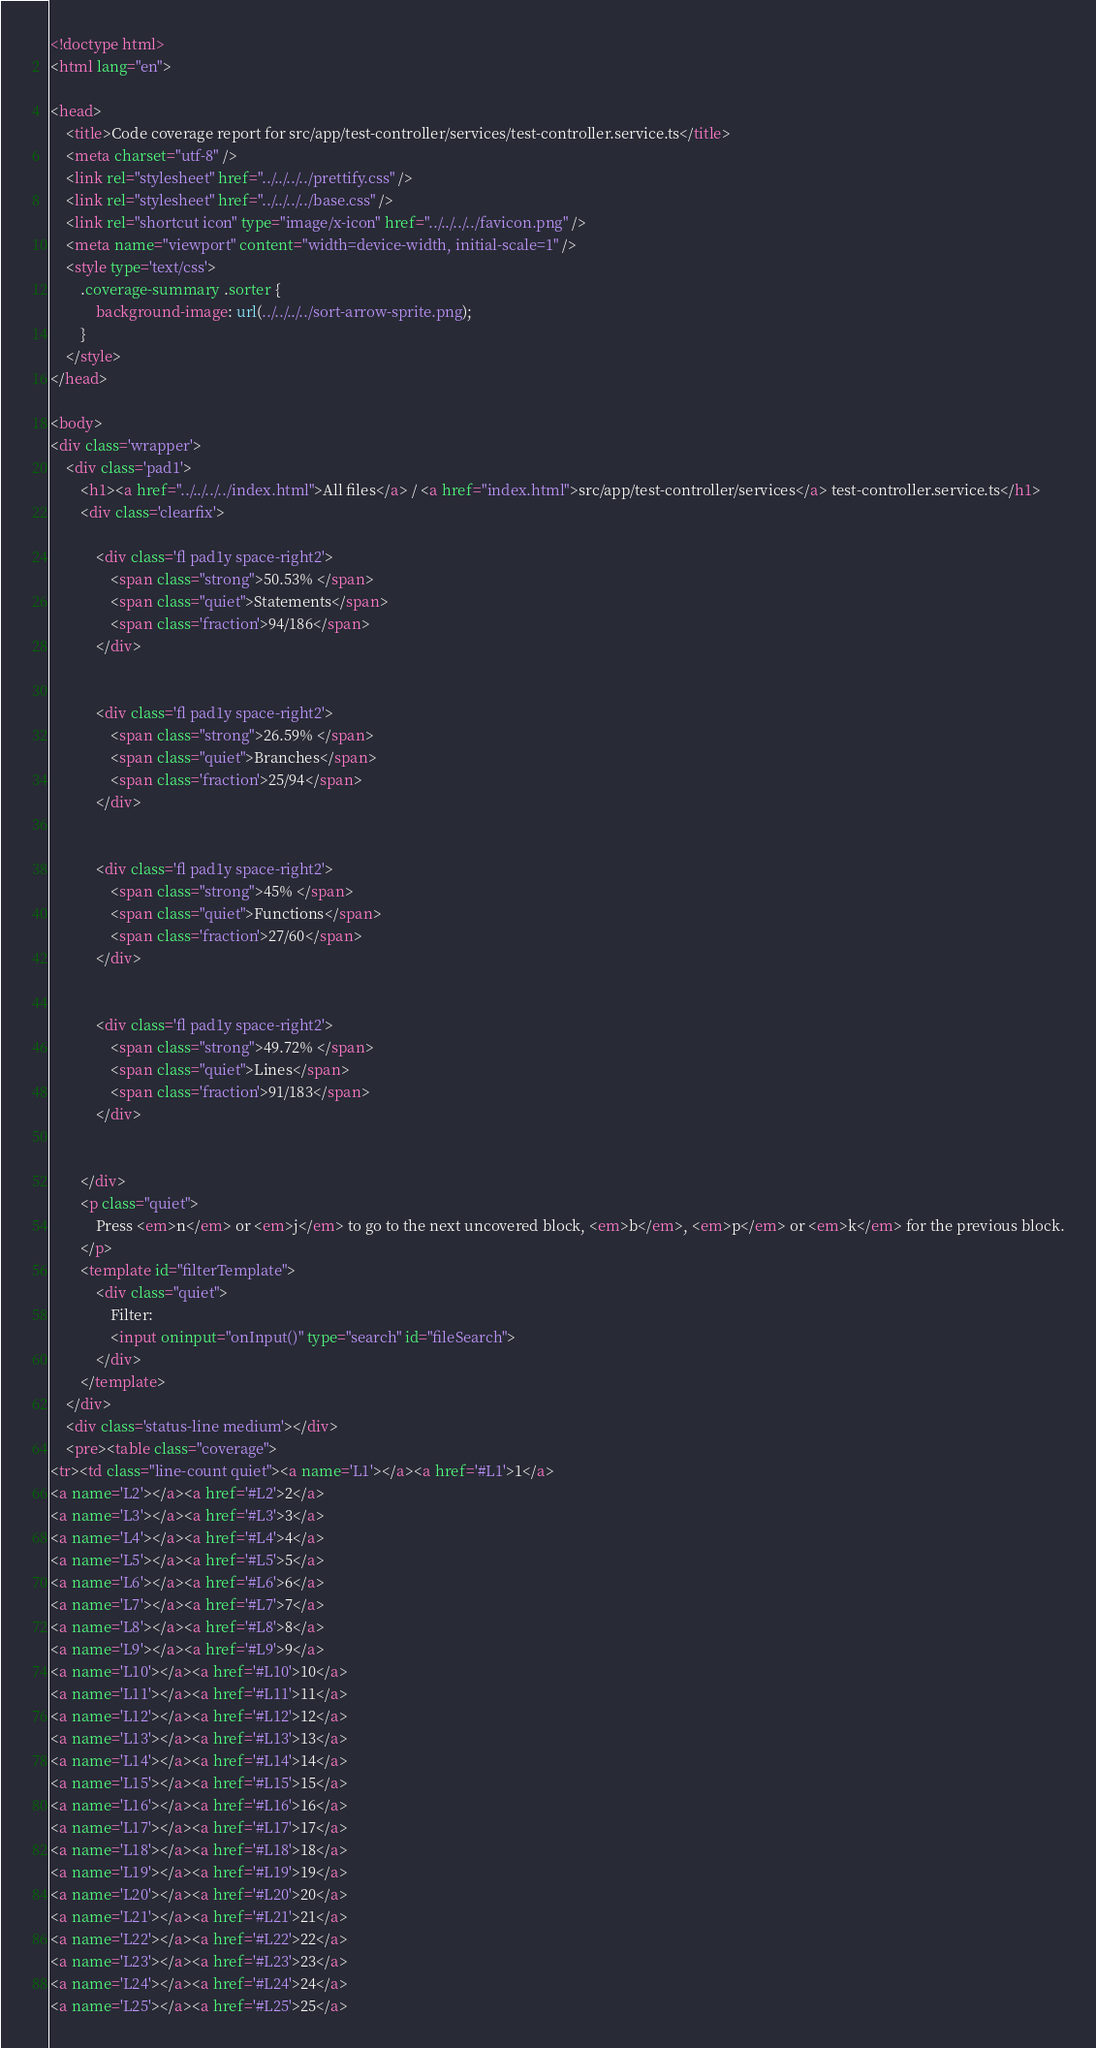<code> <loc_0><loc_0><loc_500><loc_500><_HTML_>
<!doctype html>
<html lang="en">

<head>
    <title>Code coverage report for src/app/test-controller/services/test-controller.service.ts</title>
    <meta charset="utf-8" />
    <link rel="stylesheet" href="../../../../prettify.css" />
    <link rel="stylesheet" href="../../../../base.css" />
    <link rel="shortcut icon" type="image/x-icon" href="../../../../favicon.png" />
    <meta name="viewport" content="width=device-width, initial-scale=1" />
    <style type='text/css'>
        .coverage-summary .sorter {
            background-image: url(../../../../sort-arrow-sprite.png);
        }
    </style>
</head>
    
<body>
<div class='wrapper'>
    <div class='pad1'>
        <h1><a href="../../../../index.html">All files</a> / <a href="index.html">src/app/test-controller/services</a> test-controller.service.ts</h1>
        <div class='clearfix'>
            
            <div class='fl pad1y space-right2'>
                <span class="strong">50.53% </span>
                <span class="quiet">Statements</span>
                <span class='fraction'>94/186</span>
            </div>
        
            
            <div class='fl pad1y space-right2'>
                <span class="strong">26.59% </span>
                <span class="quiet">Branches</span>
                <span class='fraction'>25/94</span>
            </div>
        
            
            <div class='fl pad1y space-right2'>
                <span class="strong">45% </span>
                <span class="quiet">Functions</span>
                <span class='fraction'>27/60</span>
            </div>
        
            
            <div class='fl pad1y space-right2'>
                <span class="strong">49.72% </span>
                <span class="quiet">Lines</span>
                <span class='fraction'>91/183</span>
            </div>
        
            
        </div>
        <p class="quiet">
            Press <em>n</em> or <em>j</em> to go to the next uncovered block, <em>b</em>, <em>p</em> or <em>k</em> for the previous block.
        </p>
        <template id="filterTemplate">
            <div class="quiet">
                Filter:
                <input oninput="onInput()" type="search" id="fileSearch">
            </div>
        </template>
    </div>
    <div class='status-line medium'></div>
    <pre><table class="coverage">
<tr><td class="line-count quiet"><a name='L1'></a><a href='#L1'>1</a>
<a name='L2'></a><a href='#L2'>2</a>
<a name='L3'></a><a href='#L3'>3</a>
<a name='L4'></a><a href='#L4'>4</a>
<a name='L5'></a><a href='#L5'>5</a>
<a name='L6'></a><a href='#L6'>6</a>
<a name='L7'></a><a href='#L7'>7</a>
<a name='L8'></a><a href='#L8'>8</a>
<a name='L9'></a><a href='#L9'>9</a>
<a name='L10'></a><a href='#L10'>10</a>
<a name='L11'></a><a href='#L11'>11</a>
<a name='L12'></a><a href='#L12'>12</a>
<a name='L13'></a><a href='#L13'>13</a>
<a name='L14'></a><a href='#L14'>14</a>
<a name='L15'></a><a href='#L15'>15</a>
<a name='L16'></a><a href='#L16'>16</a>
<a name='L17'></a><a href='#L17'>17</a>
<a name='L18'></a><a href='#L18'>18</a>
<a name='L19'></a><a href='#L19'>19</a>
<a name='L20'></a><a href='#L20'>20</a>
<a name='L21'></a><a href='#L21'>21</a>
<a name='L22'></a><a href='#L22'>22</a>
<a name='L23'></a><a href='#L23'>23</a>
<a name='L24'></a><a href='#L24'>24</a>
<a name='L25'></a><a href='#L25'>25</a></code> 